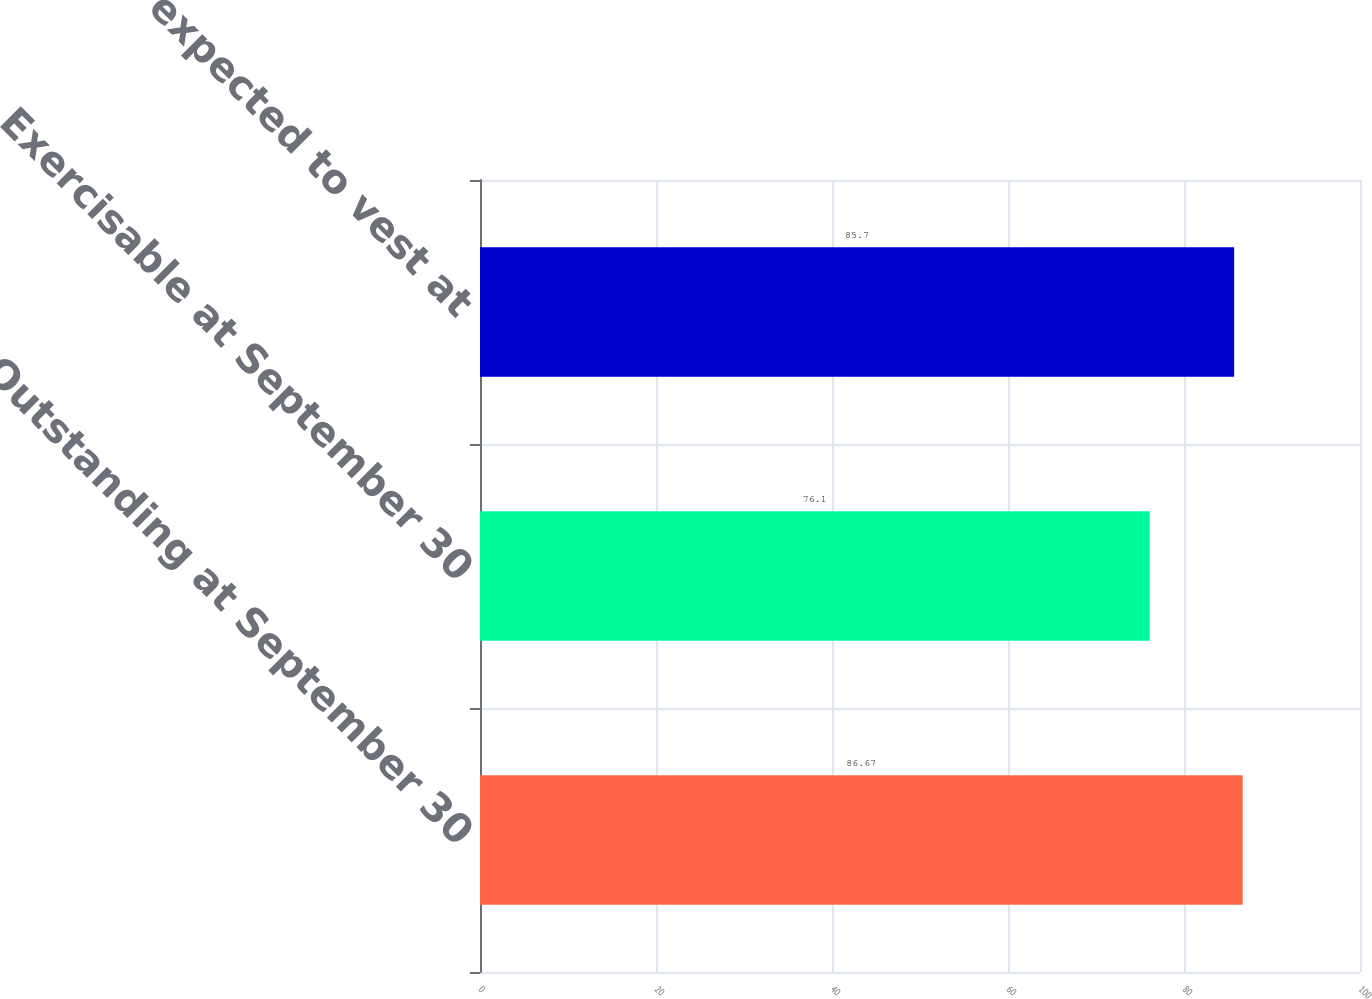Convert chart to OTSL. <chart><loc_0><loc_0><loc_500><loc_500><bar_chart><fcel>Outstanding at September 30<fcel>Exercisable at September 30<fcel>Vested and expected to vest at<nl><fcel>86.67<fcel>76.1<fcel>85.7<nl></chart> 